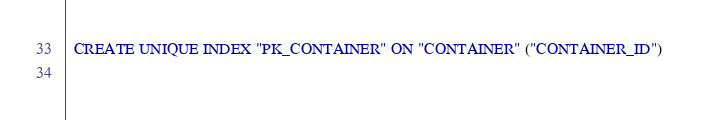<code> <loc_0><loc_0><loc_500><loc_500><_SQL_>
  CREATE UNIQUE INDEX "PK_CONTAINER" ON "CONTAINER" ("CONTAINER_ID") 
  </code> 